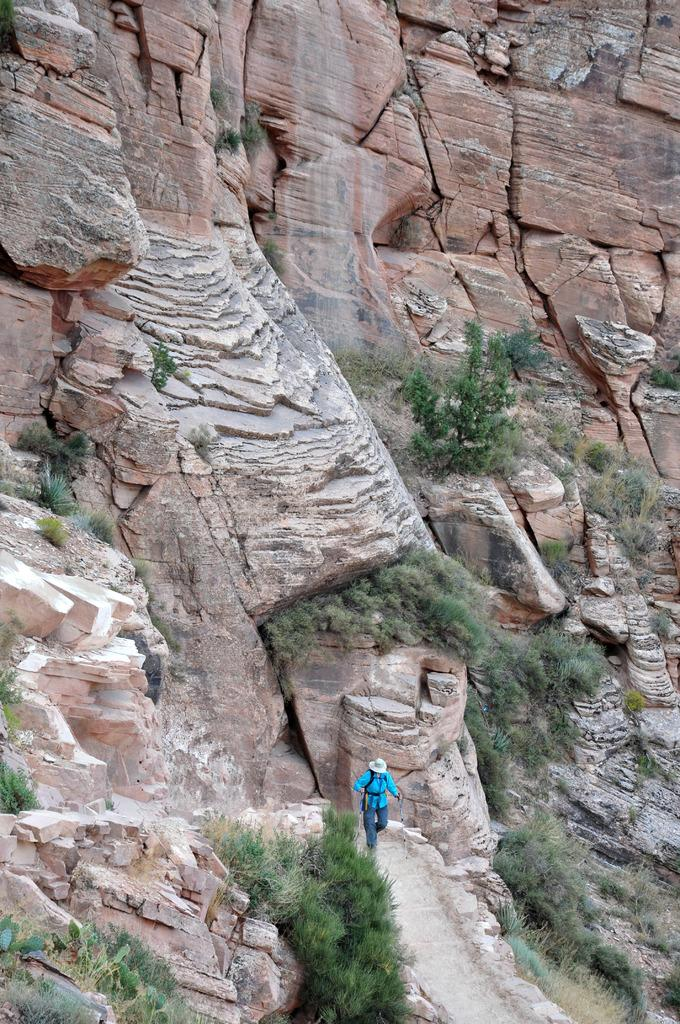Who or what is at the bottom of the image? There is a person at the bottom of the image. What type of natural elements can be seen in the image? There are trees in the image. What type of geological features are present in the background of the image? There are rocks in the background of the image. Where is the family gathering for lunch in the image? There is no family gathering or lunchroom present in the image. 